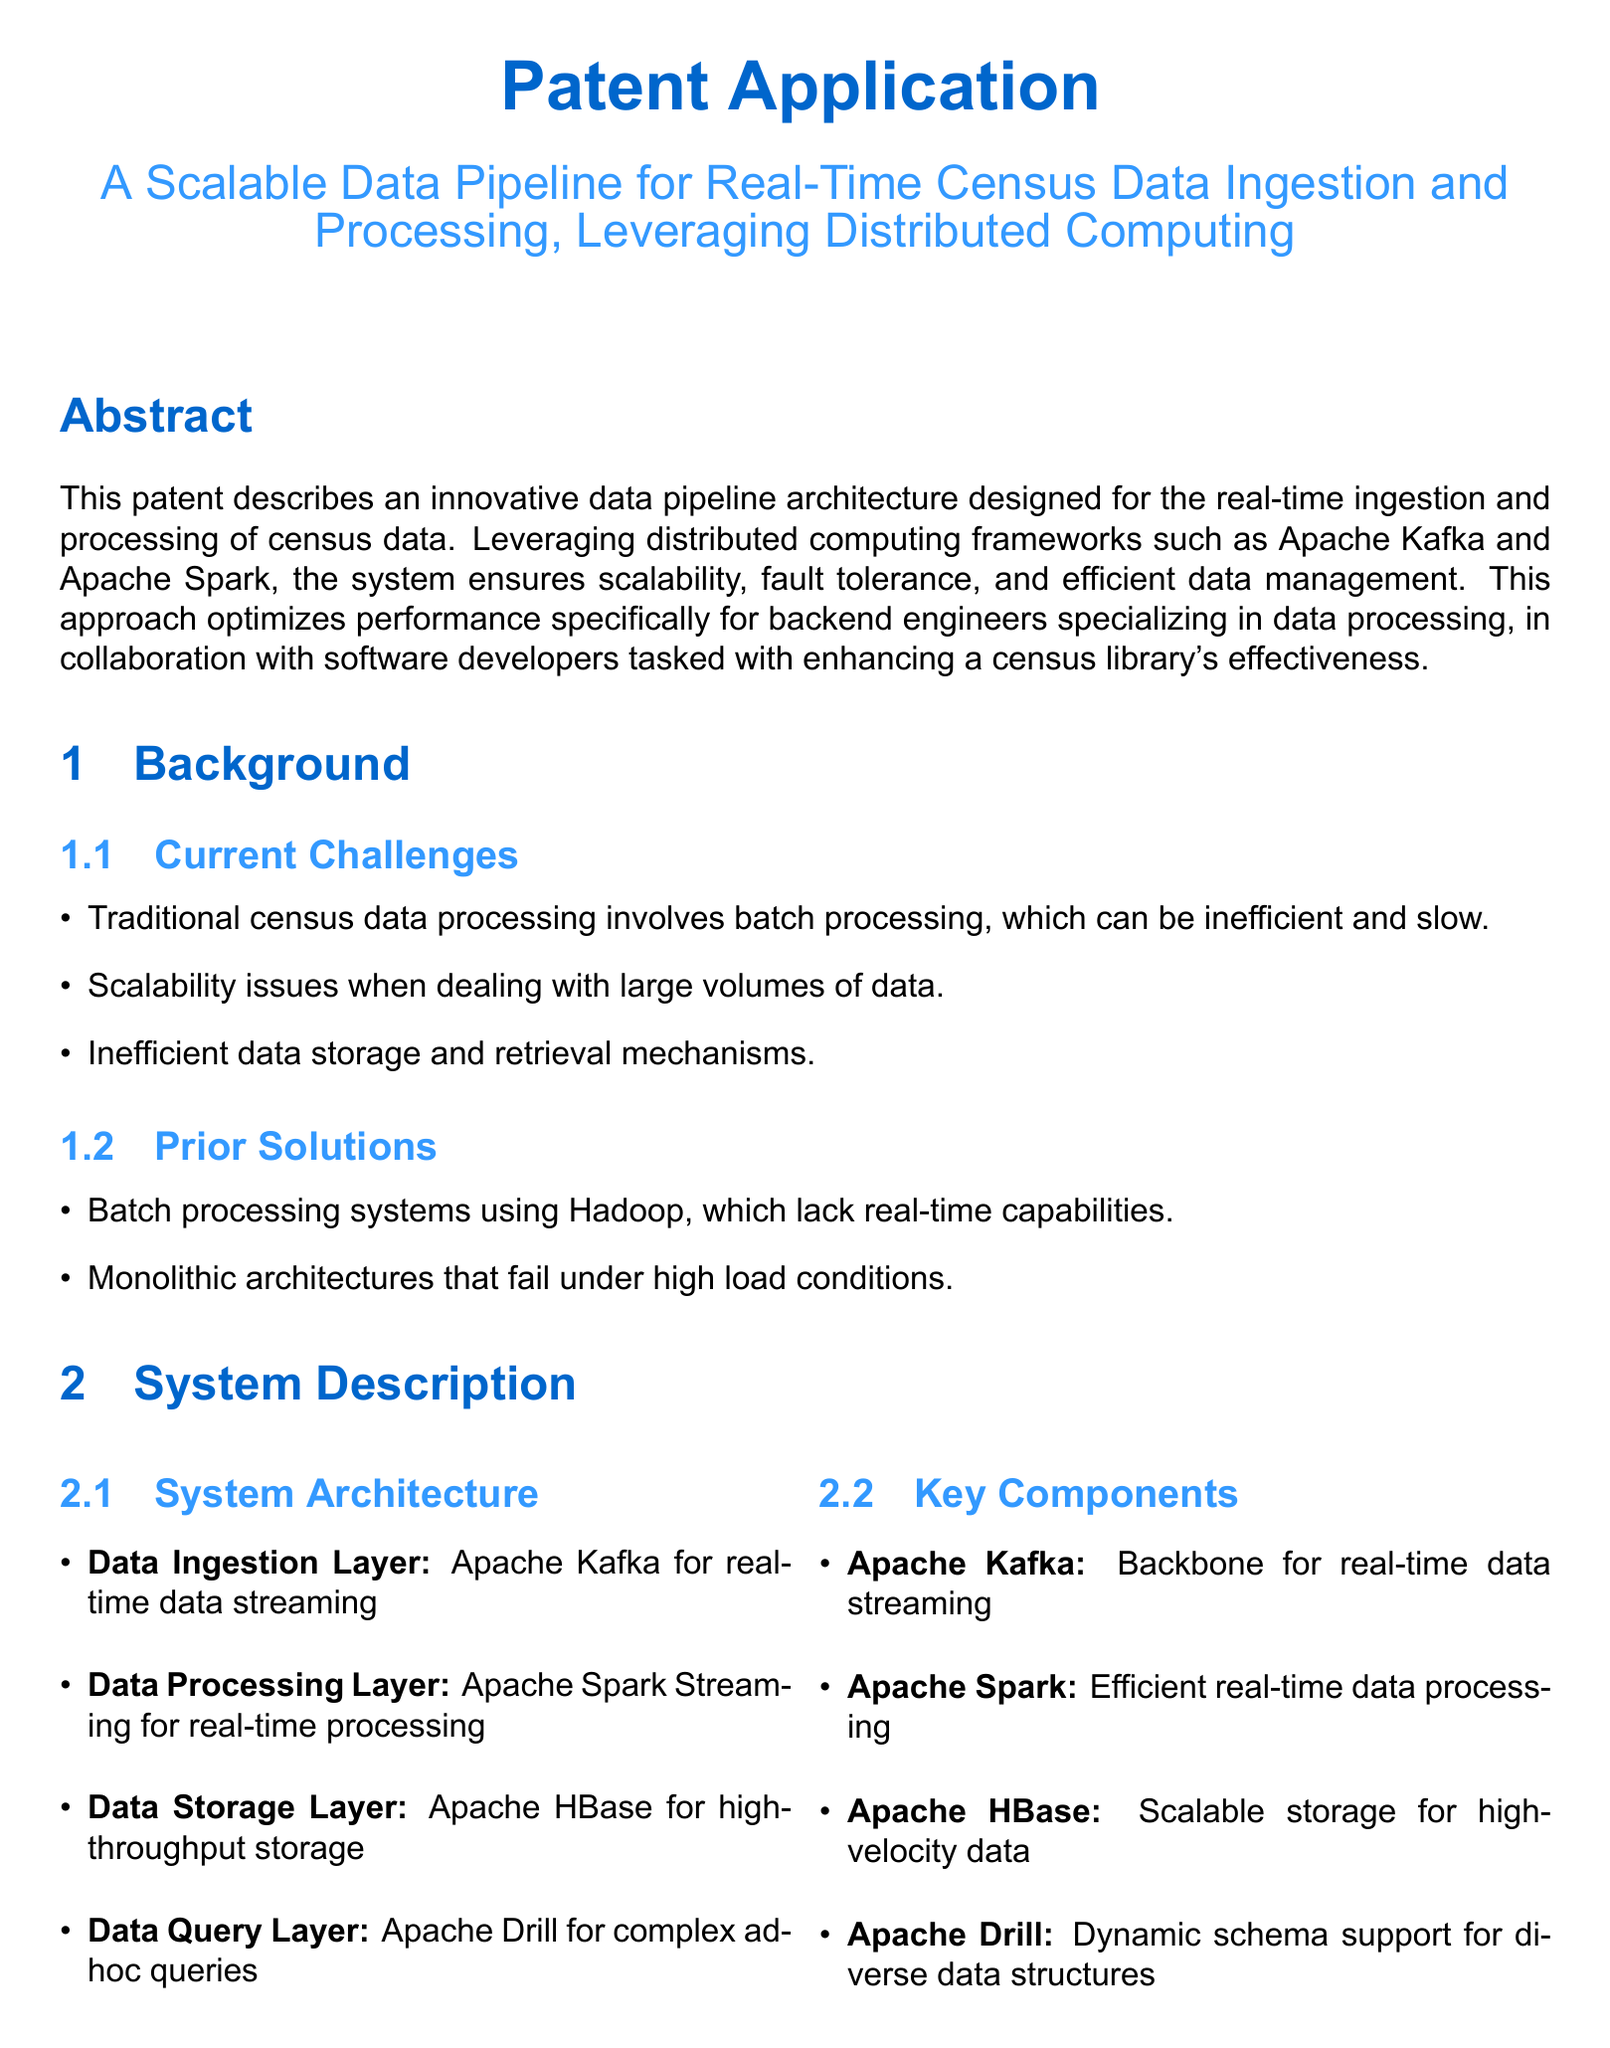What is the title of the patent application? The title is the main descriptive heading of the document, which indicates the subject matter of the patent application.
Answer: A Scalable Data Pipeline for Real-Time Census Data Ingestion and Processing, Leveraging Distributed Computing What framework is used for real-time data streaming? This information is found in the system architecture section, which lists the technologies used.
Answer: Apache Kafka What technology is employed for real-time processing? The document specifies the technology used in the data processing layer of the system.
Answer: Apache Spark Streaming What type of storage is implemented in the system? The storage type is mentioned in the system description under the data storage layer.
Answer: Apache HBase How many claims are included in the document? The number of claims is stated explicitly in the claims section of the patent application.
Answer: 3 What does the system support for scalability? This information is found under the claims section, referring to the capability of the data pipeline.
Answer: Horizontal scalability What is the purpose of Apache Drill in the system? This is identified in the key components section, which describes the role of each component.
Answer: Complex ad-hoc queries What type of engineers collaborate on this system? The document highlights the collaborative efforts relevant to the development of the data pipeline.
Answer: Backend engineers and software developers 